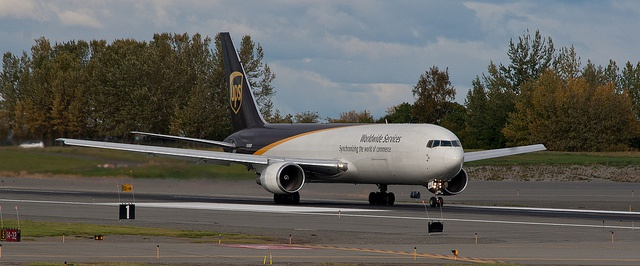Describe the objects in this image and their specific colors. I can see a airplane in darkgray, black, gray, and lightgray tones in this image. 